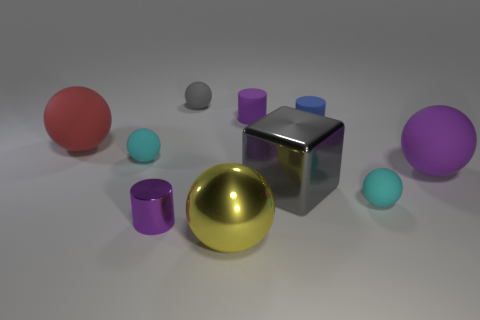There is a small object that is the same color as the big metallic block; what is its shape?
Offer a very short reply. Sphere. There is a tiny metallic object that is on the left side of the large gray cube; is its shape the same as the small cyan matte object to the right of the yellow object?
Your answer should be very brief. No. Is the number of cyan things that are to the left of the big yellow metal ball the same as the number of large green metal things?
Provide a succinct answer. No. There is another big matte object that is the same shape as the big purple object; what color is it?
Your answer should be compact. Red. Is the material of the purple cylinder in front of the red thing the same as the large gray object?
Ensure brevity in your answer.  Yes. What number of large objects are red matte cylinders or blue rubber things?
Your answer should be very brief. 0. What is the size of the gray metallic thing?
Offer a terse response. Large. Is the size of the gray metal object the same as the purple cylinder that is on the right side of the tiny purple metallic object?
Provide a succinct answer. No. How many brown objects are either big matte objects or cubes?
Your response must be concise. 0. How many rubber balls are there?
Your answer should be very brief. 5. 